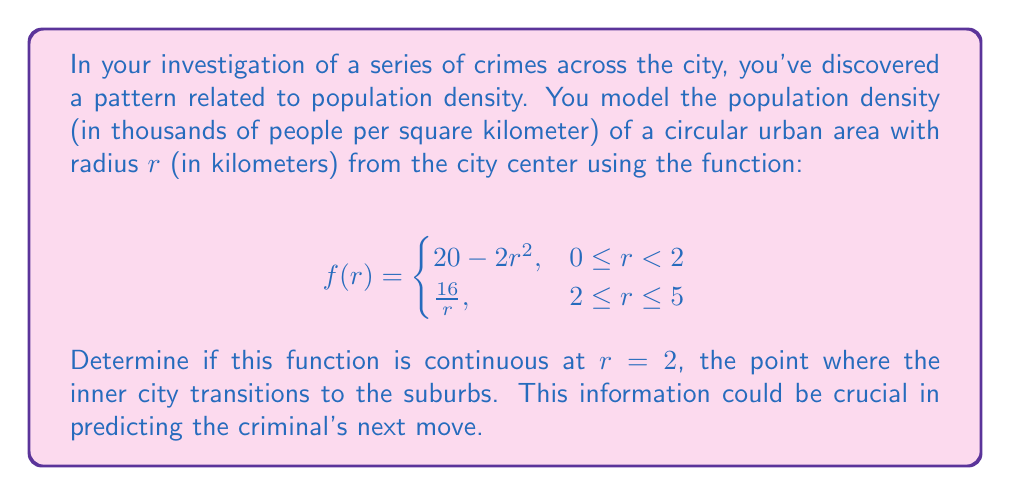Show me your answer to this math problem. To determine if the function $f(r)$ is continuous at $r = 2$, we need to check three conditions:

1. $f(r)$ is defined at $r = 2$
2. $\lim_{r \to 2^-} f(r)$ exists
3. $\lim_{r \to 2^-} f(r) = \lim_{r \to 2^+} f(r) = f(2)$

Let's check each condition:

1. $f(2)$ is defined:
   At $r = 2$, we use the second piece of the function: $f(2) = \frac{16}{2} = 8$

2. Left-hand limit:
   $$\lim_{r \to 2^-} f(r) = \lim_{r \to 2^-} (20 - 2r^2) = 20 - 2(2)^2 = 20 - 8 = 12$$

3. Right-hand limit:
   $$\lim_{r \to 2^+} f(r) = \lim_{r \to 2^+} \frac{16}{r} = \frac{16}{2} = 8$$

Now, we compare these values:
- $\lim_{r \to 2^-} f(r) = 12$
- $\lim_{r \to 2^+} f(r) = 8$
- $f(2) = 8$

We can see that the left-hand limit does not equal the right-hand limit, and the left-hand limit does not equal $f(2)$. Therefore, the function is not continuous at $r = 2$.
Answer: The function $f(r)$ is not continuous at $r = 2$. 